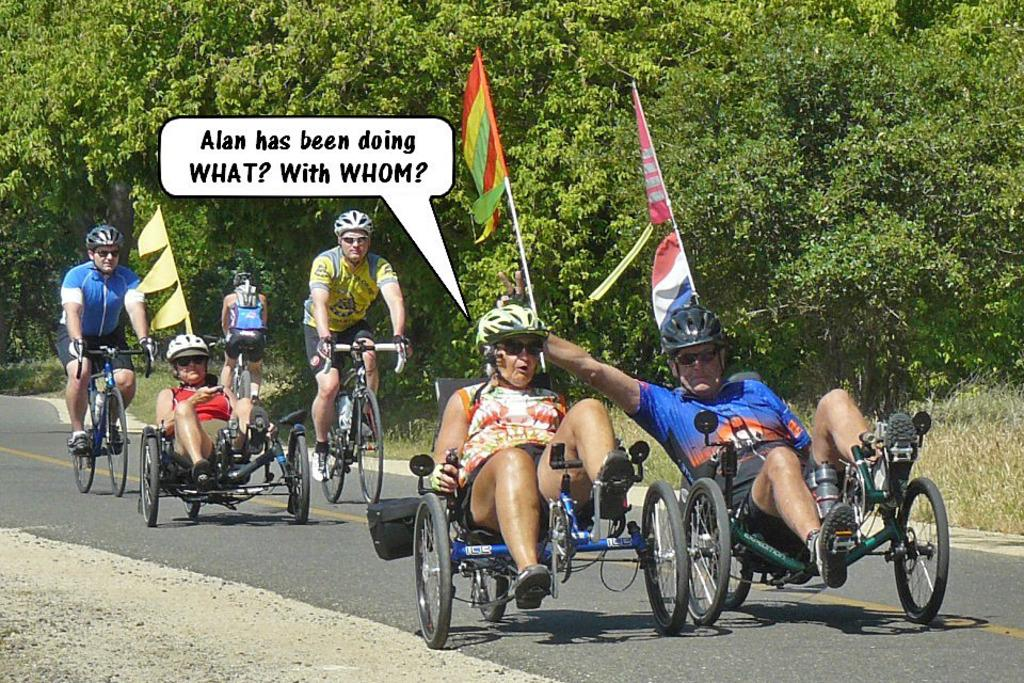Where was the image taken? The image was taken on the road. What types of vehicles are being ridden in the image? There are people riding tricycles and bicycles in the image. Is there any symbol or emblem present in the image? Yes, there is a flag in the image. What can be seen in the background of the image? There are many trees in the background of the image. What type of collar can be seen on the people riding bicycles in the image? There is: There are no collars visible on the people riding bicycles in the image. How many spiders are crawling on the flag in the image? There are no spiders present in the image, and the flag does not have any spiders crawling on it. 